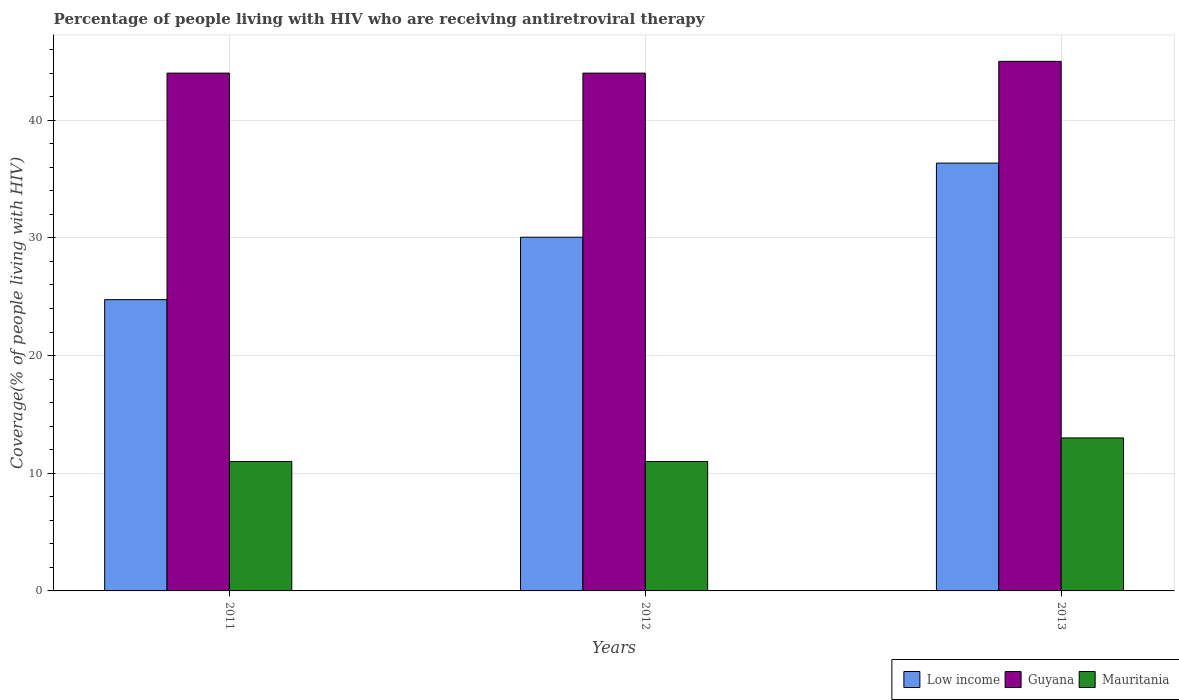How many bars are there on the 2nd tick from the right?
Keep it short and to the point. 3. What is the label of the 1st group of bars from the left?
Make the answer very short. 2011. What is the percentage of the HIV infected people who are receiving antiretroviral therapy in Mauritania in 2012?
Your answer should be compact. 11. Across all years, what is the maximum percentage of the HIV infected people who are receiving antiretroviral therapy in Mauritania?
Make the answer very short. 13. Across all years, what is the minimum percentage of the HIV infected people who are receiving antiretroviral therapy in Guyana?
Offer a terse response. 44. In which year was the percentage of the HIV infected people who are receiving antiretroviral therapy in Mauritania maximum?
Give a very brief answer. 2013. In which year was the percentage of the HIV infected people who are receiving antiretroviral therapy in Guyana minimum?
Keep it short and to the point. 2011. What is the total percentage of the HIV infected people who are receiving antiretroviral therapy in Mauritania in the graph?
Ensure brevity in your answer.  35. What is the difference between the percentage of the HIV infected people who are receiving antiretroviral therapy in Low income in 2011 and that in 2012?
Keep it short and to the point. -5.31. What is the difference between the percentage of the HIV infected people who are receiving antiretroviral therapy in Low income in 2012 and the percentage of the HIV infected people who are receiving antiretroviral therapy in Mauritania in 2013?
Your answer should be very brief. 17.06. What is the average percentage of the HIV infected people who are receiving antiretroviral therapy in Guyana per year?
Provide a short and direct response. 44.33. In the year 2013, what is the difference between the percentage of the HIV infected people who are receiving antiretroviral therapy in Guyana and percentage of the HIV infected people who are receiving antiretroviral therapy in Mauritania?
Offer a very short reply. 32. In how many years, is the percentage of the HIV infected people who are receiving antiretroviral therapy in Guyana greater than 40 %?
Provide a short and direct response. 3. What is the ratio of the percentage of the HIV infected people who are receiving antiretroviral therapy in Mauritania in 2011 to that in 2013?
Your answer should be very brief. 0.85. Is the percentage of the HIV infected people who are receiving antiretroviral therapy in Guyana in 2011 less than that in 2013?
Offer a terse response. Yes. What is the difference between the highest and the second highest percentage of the HIV infected people who are receiving antiretroviral therapy in Mauritania?
Keep it short and to the point. 2. What is the difference between the highest and the lowest percentage of the HIV infected people who are receiving antiretroviral therapy in Guyana?
Provide a short and direct response. 1. In how many years, is the percentage of the HIV infected people who are receiving antiretroviral therapy in Low income greater than the average percentage of the HIV infected people who are receiving antiretroviral therapy in Low income taken over all years?
Offer a very short reply. 1. Is the sum of the percentage of the HIV infected people who are receiving antiretroviral therapy in Low income in 2011 and 2013 greater than the maximum percentage of the HIV infected people who are receiving antiretroviral therapy in Mauritania across all years?
Ensure brevity in your answer.  Yes. What does the 2nd bar from the left in 2012 represents?
Provide a short and direct response. Guyana. What does the 2nd bar from the right in 2012 represents?
Offer a terse response. Guyana. Is it the case that in every year, the sum of the percentage of the HIV infected people who are receiving antiretroviral therapy in Low income and percentage of the HIV infected people who are receiving antiretroviral therapy in Guyana is greater than the percentage of the HIV infected people who are receiving antiretroviral therapy in Mauritania?
Provide a succinct answer. Yes. How many years are there in the graph?
Provide a succinct answer. 3. Are the values on the major ticks of Y-axis written in scientific E-notation?
Your answer should be compact. No. Does the graph contain any zero values?
Provide a succinct answer. No. What is the title of the graph?
Your response must be concise. Percentage of people living with HIV who are receiving antiretroviral therapy. Does "Nigeria" appear as one of the legend labels in the graph?
Make the answer very short. No. What is the label or title of the X-axis?
Ensure brevity in your answer.  Years. What is the label or title of the Y-axis?
Ensure brevity in your answer.  Coverage(% of people living with HIV). What is the Coverage(% of people living with HIV) in Low income in 2011?
Provide a short and direct response. 24.75. What is the Coverage(% of people living with HIV) of Guyana in 2011?
Provide a short and direct response. 44. What is the Coverage(% of people living with HIV) in Low income in 2012?
Give a very brief answer. 30.06. What is the Coverage(% of people living with HIV) of Mauritania in 2012?
Offer a terse response. 11. What is the Coverage(% of people living with HIV) of Low income in 2013?
Offer a terse response. 36.35. What is the Coverage(% of people living with HIV) of Guyana in 2013?
Your response must be concise. 45. Across all years, what is the maximum Coverage(% of people living with HIV) in Low income?
Keep it short and to the point. 36.35. Across all years, what is the maximum Coverage(% of people living with HIV) in Guyana?
Keep it short and to the point. 45. Across all years, what is the maximum Coverage(% of people living with HIV) of Mauritania?
Keep it short and to the point. 13. Across all years, what is the minimum Coverage(% of people living with HIV) in Low income?
Your answer should be very brief. 24.75. Across all years, what is the minimum Coverage(% of people living with HIV) in Mauritania?
Offer a very short reply. 11. What is the total Coverage(% of people living with HIV) in Low income in the graph?
Ensure brevity in your answer.  91.16. What is the total Coverage(% of people living with HIV) of Guyana in the graph?
Offer a very short reply. 133. What is the difference between the Coverage(% of people living with HIV) in Low income in 2011 and that in 2012?
Make the answer very short. -5.31. What is the difference between the Coverage(% of people living with HIV) in Guyana in 2011 and that in 2012?
Your response must be concise. 0. What is the difference between the Coverage(% of people living with HIV) in Low income in 2011 and that in 2013?
Keep it short and to the point. -11.6. What is the difference between the Coverage(% of people living with HIV) in Low income in 2012 and that in 2013?
Your answer should be very brief. -6.3. What is the difference between the Coverage(% of people living with HIV) in Mauritania in 2012 and that in 2013?
Give a very brief answer. -2. What is the difference between the Coverage(% of people living with HIV) in Low income in 2011 and the Coverage(% of people living with HIV) in Guyana in 2012?
Offer a very short reply. -19.25. What is the difference between the Coverage(% of people living with HIV) in Low income in 2011 and the Coverage(% of people living with HIV) in Mauritania in 2012?
Provide a succinct answer. 13.75. What is the difference between the Coverage(% of people living with HIV) in Low income in 2011 and the Coverage(% of people living with HIV) in Guyana in 2013?
Keep it short and to the point. -20.25. What is the difference between the Coverage(% of people living with HIV) of Low income in 2011 and the Coverage(% of people living with HIV) of Mauritania in 2013?
Offer a terse response. 11.75. What is the difference between the Coverage(% of people living with HIV) of Guyana in 2011 and the Coverage(% of people living with HIV) of Mauritania in 2013?
Make the answer very short. 31. What is the difference between the Coverage(% of people living with HIV) in Low income in 2012 and the Coverage(% of people living with HIV) in Guyana in 2013?
Make the answer very short. -14.94. What is the difference between the Coverage(% of people living with HIV) of Low income in 2012 and the Coverage(% of people living with HIV) of Mauritania in 2013?
Your response must be concise. 17.06. What is the average Coverage(% of people living with HIV) in Low income per year?
Your response must be concise. 30.39. What is the average Coverage(% of people living with HIV) in Guyana per year?
Provide a succinct answer. 44.33. What is the average Coverage(% of people living with HIV) of Mauritania per year?
Keep it short and to the point. 11.67. In the year 2011, what is the difference between the Coverage(% of people living with HIV) of Low income and Coverage(% of people living with HIV) of Guyana?
Ensure brevity in your answer.  -19.25. In the year 2011, what is the difference between the Coverage(% of people living with HIV) in Low income and Coverage(% of people living with HIV) in Mauritania?
Your answer should be compact. 13.75. In the year 2012, what is the difference between the Coverage(% of people living with HIV) of Low income and Coverage(% of people living with HIV) of Guyana?
Provide a short and direct response. -13.94. In the year 2012, what is the difference between the Coverage(% of people living with HIV) of Low income and Coverage(% of people living with HIV) of Mauritania?
Keep it short and to the point. 19.06. In the year 2012, what is the difference between the Coverage(% of people living with HIV) of Guyana and Coverage(% of people living with HIV) of Mauritania?
Give a very brief answer. 33. In the year 2013, what is the difference between the Coverage(% of people living with HIV) of Low income and Coverage(% of people living with HIV) of Guyana?
Make the answer very short. -8.65. In the year 2013, what is the difference between the Coverage(% of people living with HIV) of Low income and Coverage(% of people living with HIV) of Mauritania?
Offer a very short reply. 23.35. What is the ratio of the Coverage(% of people living with HIV) in Low income in 2011 to that in 2012?
Provide a short and direct response. 0.82. What is the ratio of the Coverage(% of people living with HIV) of Guyana in 2011 to that in 2012?
Ensure brevity in your answer.  1. What is the ratio of the Coverage(% of people living with HIV) of Mauritania in 2011 to that in 2012?
Provide a short and direct response. 1. What is the ratio of the Coverage(% of people living with HIV) in Low income in 2011 to that in 2013?
Provide a succinct answer. 0.68. What is the ratio of the Coverage(% of people living with HIV) in Guyana in 2011 to that in 2013?
Offer a terse response. 0.98. What is the ratio of the Coverage(% of people living with HIV) of Mauritania in 2011 to that in 2013?
Your answer should be compact. 0.85. What is the ratio of the Coverage(% of people living with HIV) in Low income in 2012 to that in 2013?
Offer a very short reply. 0.83. What is the ratio of the Coverage(% of people living with HIV) in Guyana in 2012 to that in 2013?
Provide a succinct answer. 0.98. What is the ratio of the Coverage(% of people living with HIV) of Mauritania in 2012 to that in 2013?
Your answer should be compact. 0.85. What is the difference between the highest and the second highest Coverage(% of people living with HIV) in Low income?
Your response must be concise. 6.3. What is the difference between the highest and the second highest Coverage(% of people living with HIV) in Mauritania?
Give a very brief answer. 2. What is the difference between the highest and the lowest Coverage(% of people living with HIV) of Low income?
Your answer should be compact. 11.6. What is the difference between the highest and the lowest Coverage(% of people living with HIV) in Guyana?
Provide a short and direct response. 1. What is the difference between the highest and the lowest Coverage(% of people living with HIV) of Mauritania?
Ensure brevity in your answer.  2. 